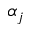Convert formula to latex. <formula><loc_0><loc_0><loc_500><loc_500>\alpha _ { j }</formula> 